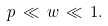Convert formula to latex. <formula><loc_0><loc_0><loc_500><loc_500>p \, \ll \, w \, \ll \, 1 .</formula> 